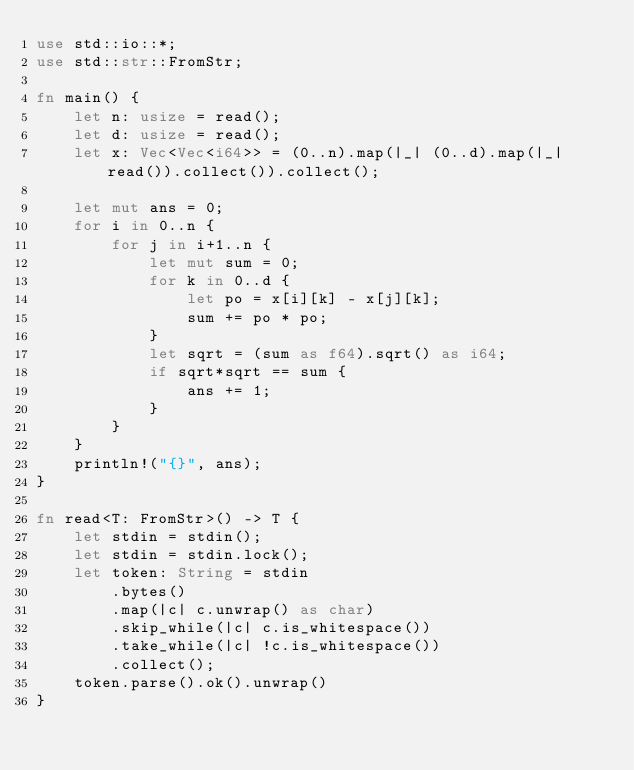Convert code to text. <code><loc_0><loc_0><loc_500><loc_500><_Rust_>use std::io::*;
use std::str::FromStr;

fn main() {
    let n: usize = read();
    let d: usize = read();
    let x: Vec<Vec<i64>> = (0..n).map(|_| (0..d).map(|_| read()).collect()).collect();

    let mut ans = 0;
    for i in 0..n {
        for j in i+1..n {
            let mut sum = 0;
            for k in 0..d {
                let po = x[i][k] - x[j][k];
                sum += po * po;
            }
            let sqrt = (sum as f64).sqrt() as i64;
            if sqrt*sqrt == sum {
                ans += 1;
            }
        }
    }
    println!("{}", ans);
}

fn read<T: FromStr>() -> T {
    let stdin = stdin();
    let stdin = stdin.lock();
    let token: String = stdin
        .bytes()
        .map(|c| c.unwrap() as char)
        .skip_while(|c| c.is_whitespace())
        .take_while(|c| !c.is_whitespace())
        .collect();
    token.parse().ok().unwrap()
}
</code> 